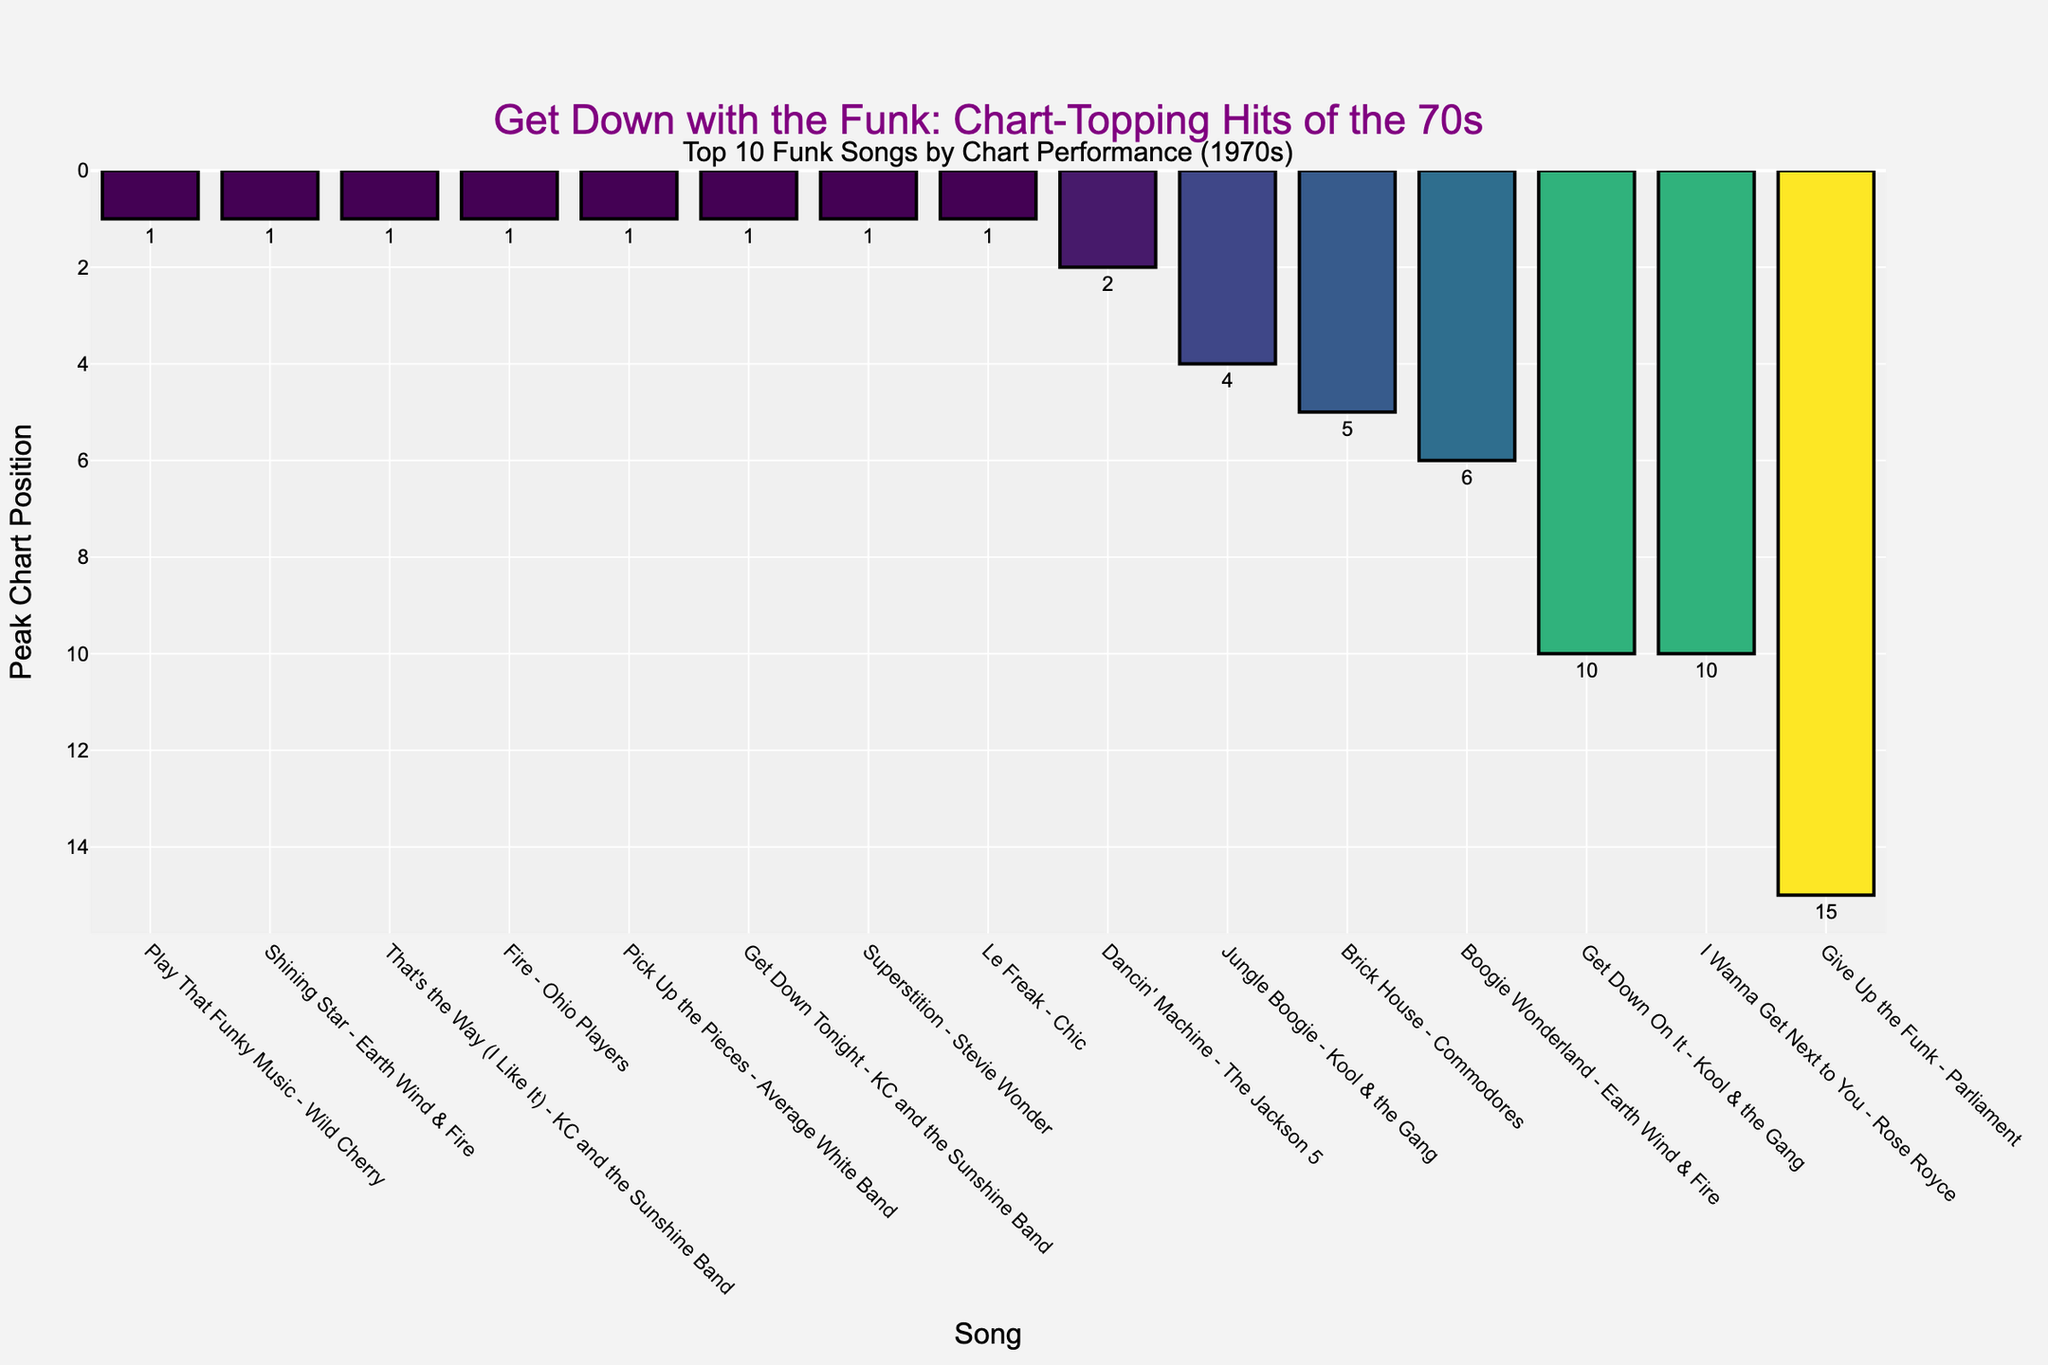Which song has the highest peak position? By looking at the bar chart, we see multiple songs with a peak position of 1, including "Play That Funky Music," "Shining Star," "That's the Way (I Like It)," "Fire," "Pick Up the Pieces," "Get Down Tonight," "Superstition," and "Le Freak."
Answer: "Play That Funky Music," "Shining Star," "That's the Way (I Like It)," "Fire," "Pick Up the Pieces," "Get Down Tonight," "Superstition," "Le Freak" Which song has the lowest peak position? By looking at the highest value on the y-axis, we see that "Give Up the Funk" by Parliament has the peak position of 15, which is the highest number in this set, indicating the lowest chart performance.
Answer: "Give Up the Funk" What is the average peak position of the songs? To calculate the average peak position, sum all the peak positions and divide by the number of songs. The sum is 1+1+1+5+1+15+4+1+1+1+6+1+2+10, which equals 51. There are 14 songs, so the average is 51/14 ≈ 3.64.
Answer: 3.64 Which two songs have a peak position of 10? By observing the chart, we can see that "Get Down On It" by Kool & the Gang and "I Wanna Get Next to You" by Rose Royce both have a peak position of 10.
Answer: "Get Down On It," "I Wanna Get Next to You" How many songs have a peak position of 1? By counting the bars with the peak position of 1, we observe that there are eight such songs: "Play That Funky Music," "Shining Star," "That's the Way (I Like It)," "Fire," "Pick Up the Pieces," "Get Down Tonight," "Superstition," "Le Freak."
Answer: 8 Which song by Earth Wind & Fire has a higher chart performance? By comparing the peak positions of the two Earth Wind & Fire songs on the chart, "Shining Star" at position 1 is higher than "Boogie Wonderland" at position 6.
Answer: "Shining Star" What is the difference in peak position between "Dancin' Machine" and "Brick House"? "Dancin' Machine" has a peak position of 2, and "Brick House" has a peak position of 5. The difference is calculated as 5 - 2 = 3.
Answer: 3 Which song by KC and the Sunshine Band has the highest peak position? "That's the Way (I Like It)" and "Get Down Tonight" both share the highest peak position of 1 among the songs by KC and the Sunshine Band.
Answer: "That's the Way (I Like It)," "Get Down Tonight" Are there more songs with a peak position equal to or higher than 10 or lower than 10? To determine this, count the songs with peak positions equal to or higher than 10 and those lower than 10. There are three songs equal or higher (peak positions: 10, 10, 15), and eleven songs lower. Thus, there are more songs with peak positions lower than 10.
Answer: More songs with peak positions lower than 10 